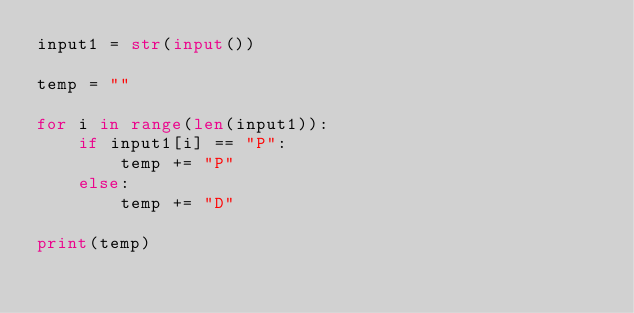Convert code to text. <code><loc_0><loc_0><loc_500><loc_500><_Python_>input1 = str(input())

temp = ""

for i in range(len(input1)):
    if input1[i] == "P":
        temp += "P"
    else:
        temp += "D"
        
print(temp)</code> 